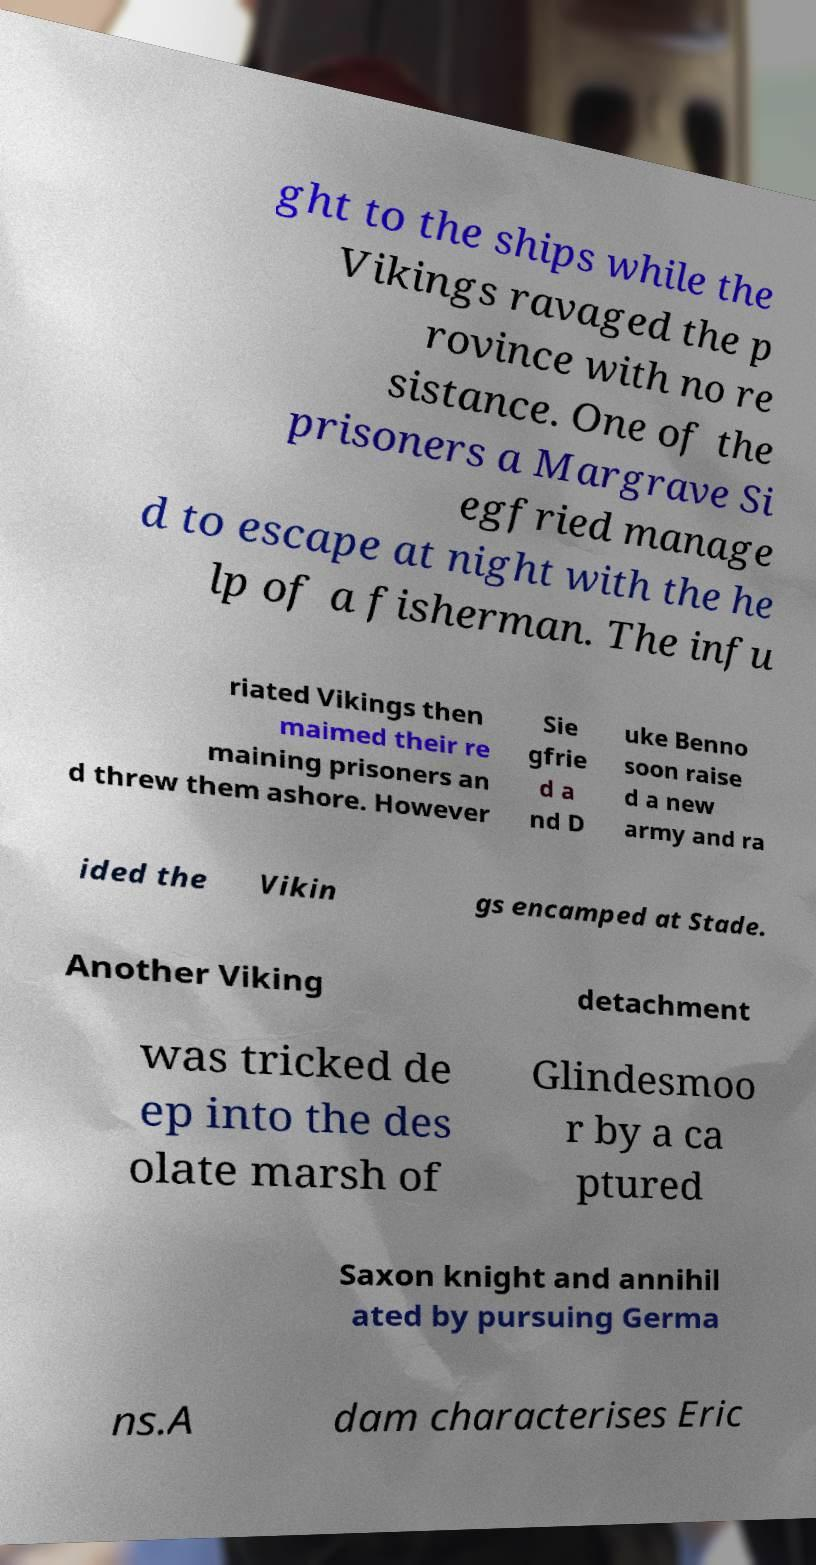For documentation purposes, I need the text within this image transcribed. Could you provide that? ght to the ships while the Vikings ravaged the p rovince with no re sistance. One of the prisoners a Margrave Si egfried manage d to escape at night with the he lp of a fisherman. The infu riated Vikings then maimed their re maining prisoners an d threw them ashore. However Sie gfrie d a nd D uke Benno soon raise d a new army and ra ided the Vikin gs encamped at Stade. Another Viking detachment was tricked de ep into the des olate marsh of Glindesmoo r by a ca ptured Saxon knight and annihil ated by pursuing Germa ns.A dam characterises Eric 